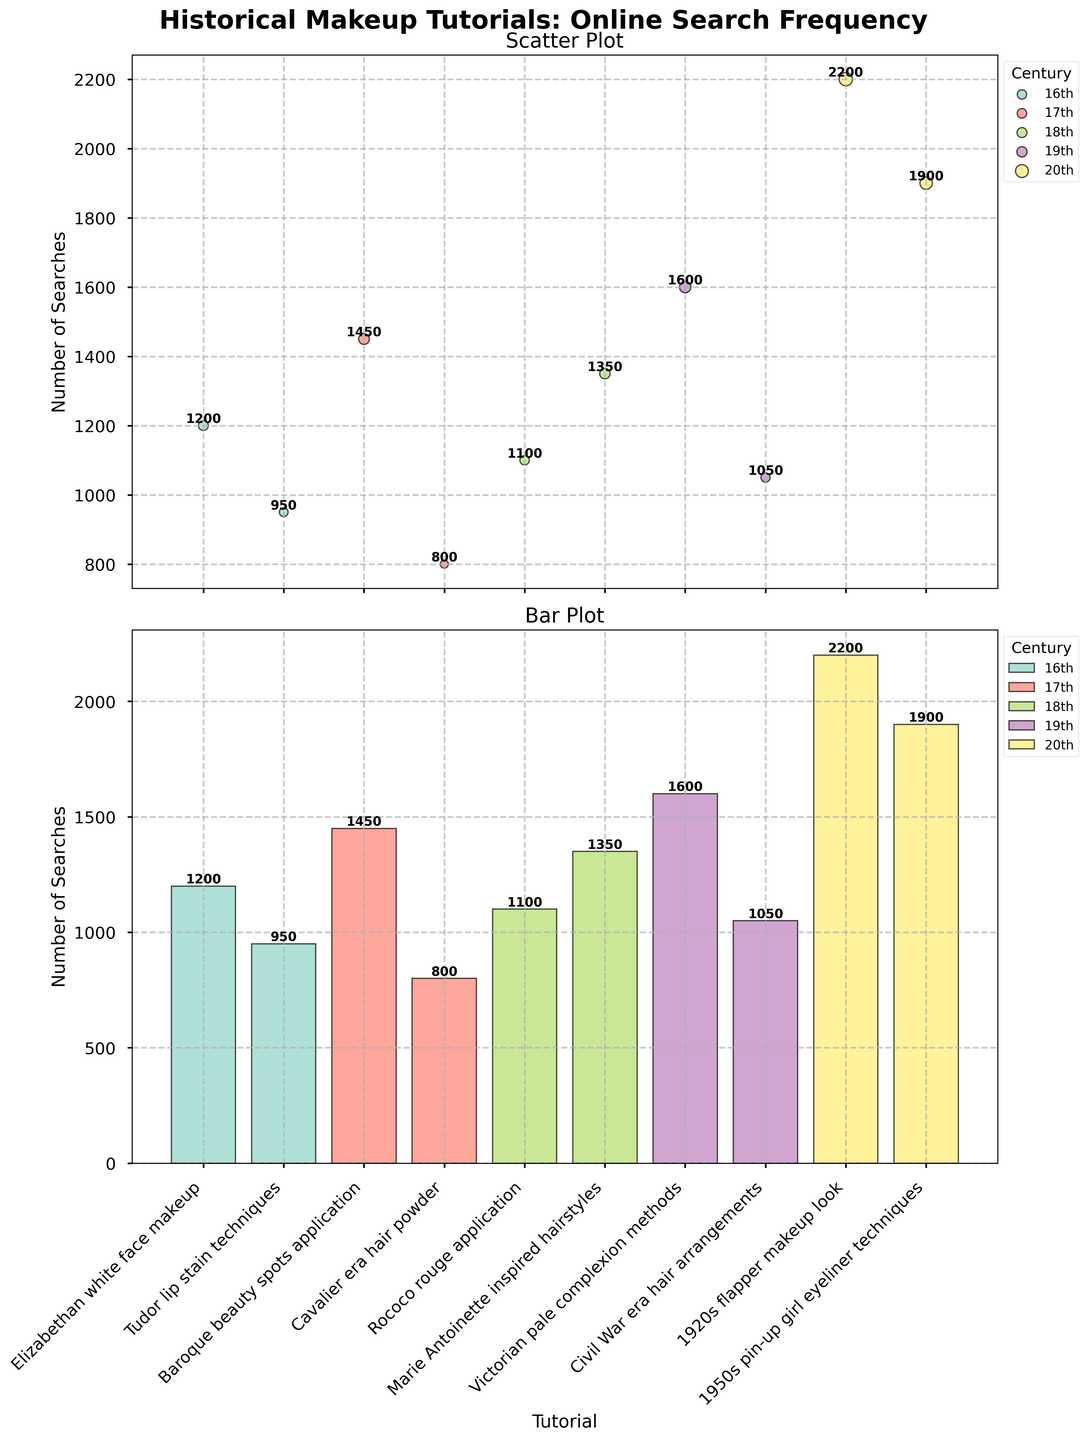Which century has the highest total number of searches across all tutorials? Summing the searches for each tutorial within each century, we find that the 20th century has 4,100 searches (1920s flapper makeup look: 2200 + 1950s pin-up girl eyeliner techniques: 1900). This is higher than any other century.
Answer: 20th What is the total number of searches for the 18th-century tutorials? Adding up the searches for Rococo rouge application and Marie Antoinette inspired hairstyles: 1100 + 1350 = 2,450.
Answer: 2,450 Which tutorial has the least number of searches? The Cavalier era hair powder tutorial has 800 searches, which is the lowest among all the tutorials listed.
Answer: Cavalier era hair powder How does the search frequency for 19th-century tutorials compare to 17th-century tutorials? The total search frequency for 19th-century tutorials is 2,650 (Victorian pale complexion methods: 1600 + Civil War era hair arrangements: 1050). For the 17th-century tutorials, it is 2,250 (Baroque beauty spots application: 1450 + Cavalier era hair powder: 800). The 19th-century tutorials have a higher total search frequency.
Answer: 19th-century higher Which tutorial in the 16th century has more searches, and by how much? Comparing Elizabethan white face makeup with 1200 searches and Tudor lip stain techniques with 950 searches, we find Elizabethan white face makeup has 250 more searches (1200 - 950 = 250).
Answer: Elizabethan white face makeup, by 250 Which century has the most variation in search frequencies between its tutorials? The difference between the highest and lowest search frequencies for each century is: 
16th century: 1200 - 950 = 250
17th century: 1450 - 800 = 650
18th century: 1350 - 1100 = 250
19th century: 1600 - 1050 = 550
20th century: 2200 - 1900 = 300
The 17th century shows the most variation with a 650 search difference.
Answer: 17th century What is the most searched tutorial overall? The 1920s flapper makeup look tutorial received the highest number of searches, with 2,200 searches.
Answer: 1920s flapper makeup look In the scatter plot, which century's points are marked with the largest circles? Each point's size represents the number of searches, so the largest circles are for the tutorials with the highest number of searches. In the scatter plot, the tutorials from the 20th century, especially the 1920s flapper makeup look, are marked with the largest circles.
Answer: 20th century What range of search frequencies does the scatter plot cover? Observing the scatter plot, the data points range from the lowest search frequency (800 searches for Cavalier era hair powder) to the highest (2,200 searches for 1920s flapper makeup look).
Answer: 800 to 2,200 How are the tutorials categorized in both plots? The tutorials are categorized by century, as shown by the distinct colors for each century in both the scatter plot and bar plot.
Answer: By century 